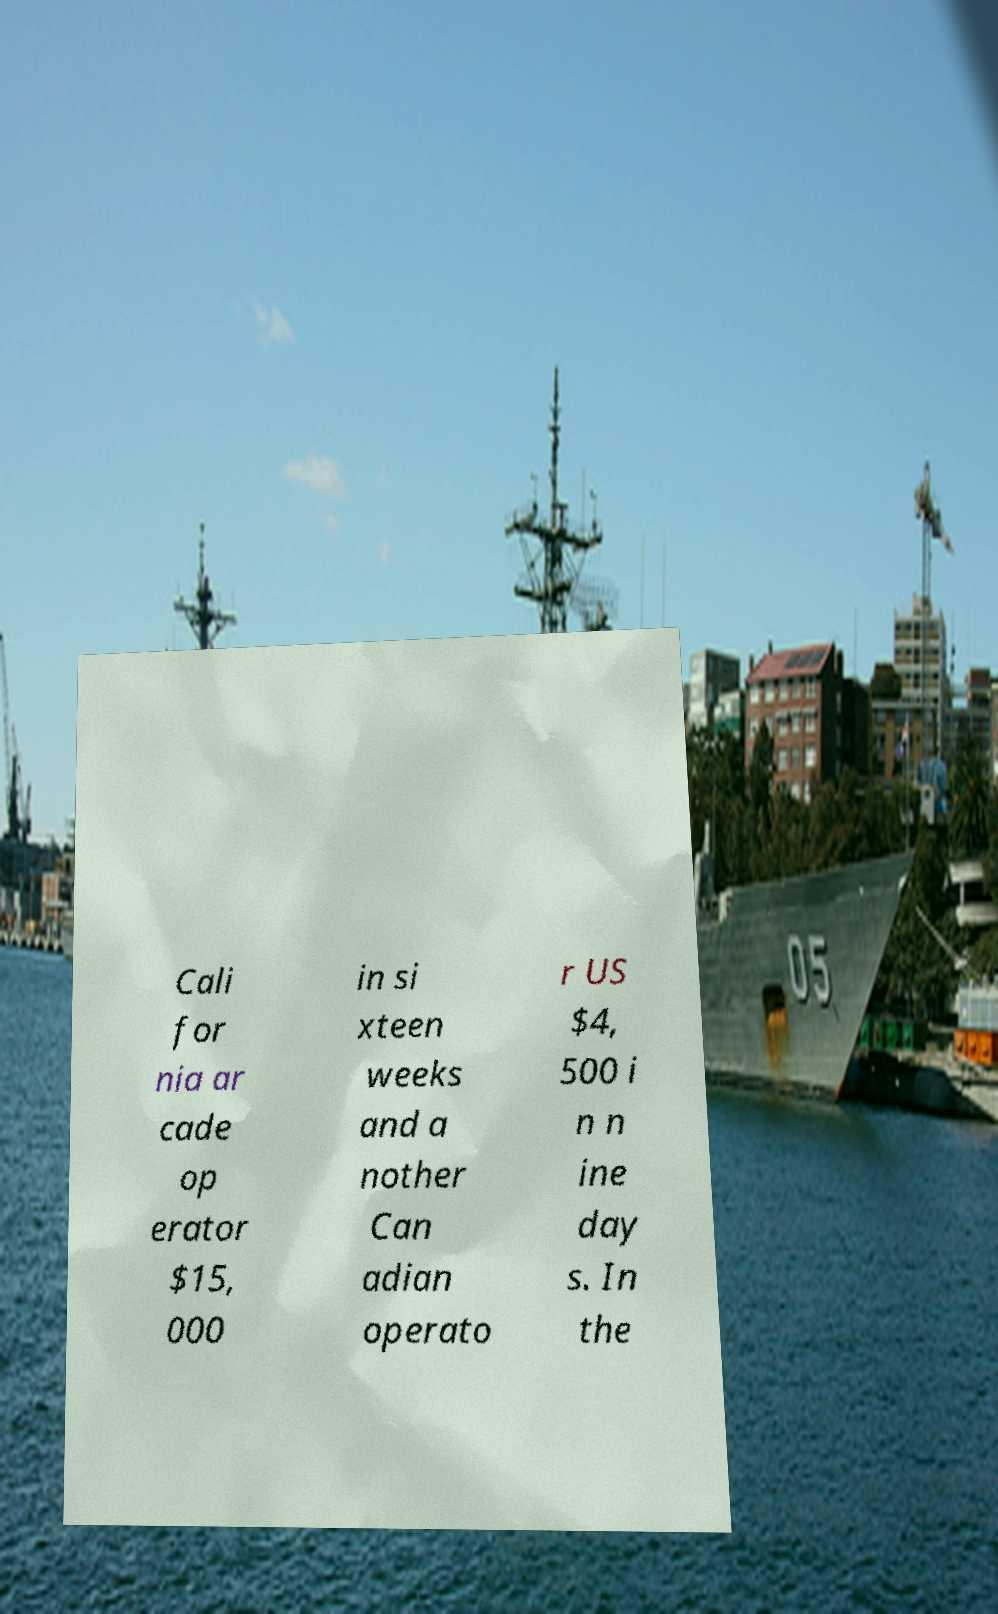Can you read and provide the text displayed in the image?This photo seems to have some interesting text. Can you extract and type it out for me? Cali for nia ar cade op erator $15, 000 in si xteen weeks and a nother Can adian operato r US $4, 500 i n n ine day s. In the 